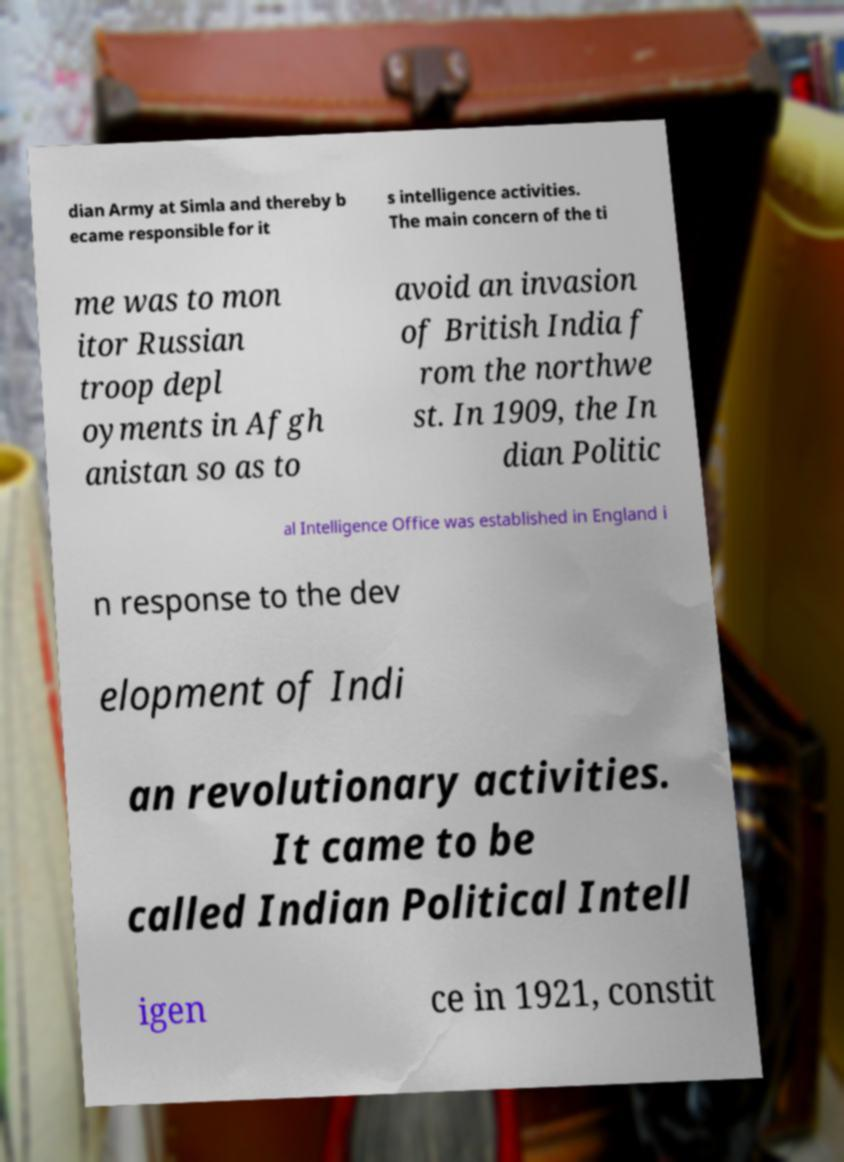Could you extract and type out the text from this image? dian Army at Simla and thereby b ecame responsible for it s intelligence activities. The main concern of the ti me was to mon itor Russian troop depl oyments in Afgh anistan so as to avoid an invasion of British India f rom the northwe st. In 1909, the In dian Politic al Intelligence Office was established in England i n response to the dev elopment of Indi an revolutionary activities. It came to be called Indian Political Intell igen ce in 1921, constit 